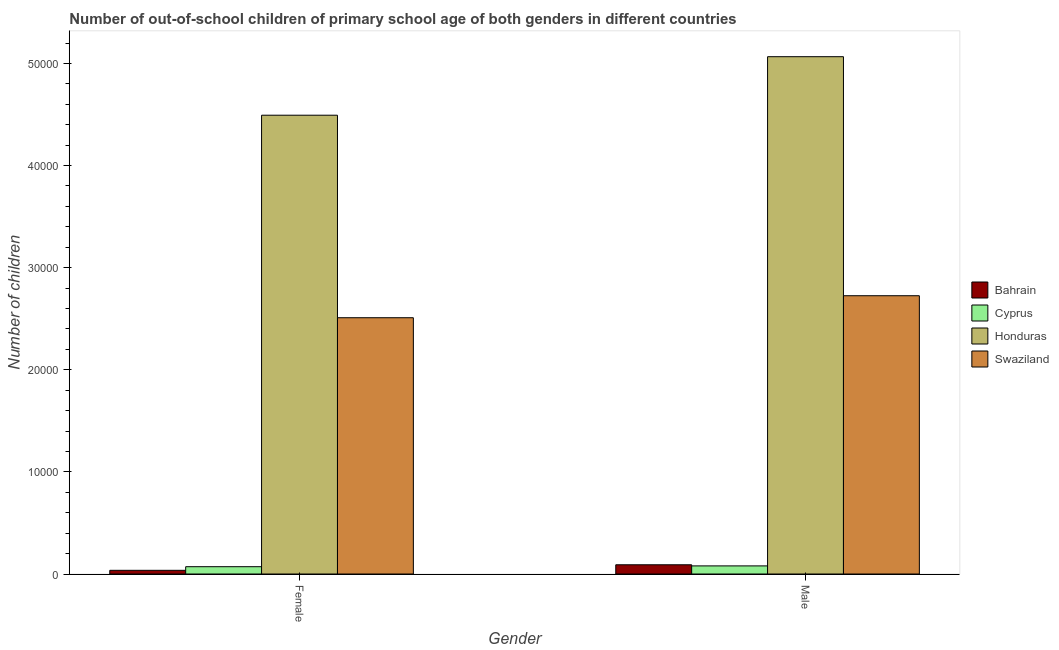How many different coloured bars are there?
Make the answer very short. 4. Are the number of bars per tick equal to the number of legend labels?
Offer a terse response. Yes. What is the label of the 1st group of bars from the left?
Make the answer very short. Female. What is the number of female out-of-school students in Honduras?
Your answer should be compact. 4.49e+04. Across all countries, what is the maximum number of female out-of-school students?
Provide a succinct answer. 4.49e+04. Across all countries, what is the minimum number of female out-of-school students?
Give a very brief answer. 360. In which country was the number of female out-of-school students maximum?
Keep it short and to the point. Honduras. In which country was the number of female out-of-school students minimum?
Make the answer very short. Bahrain. What is the total number of male out-of-school students in the graph?
Your response must be concise. 7.96e+04. What is the difference between the number of female out-of-school students in Swaziland and that in Cyprus?
Offer a terse response. 2.44e+04. What is the difference between the number of male out-of-school students in Bahrain and the number of female out-of-school students in Swaziland?
Make the answer very short. -2.42e+04. What is the average number of male out-of-school students per country?
Your response must be concise. 1.99e+04. What is the difference between the number of male out-of-school students and number of female out-of-school students in Cyprus?
Make the answer very short. 78. In how many countries, is the number of male out-of-school students greater than 12000 ?
Provide a succinct answer. 2. What is the ratio of the number of male out-of-school students in Swaziland to that in Cyprus?
Your answer should be compact. 34.37. What does the 1st bar from the left in Male represents?
Make the answer very short. Bahrain. What does the 1st bar from the right in Female represents?
Offer a terse response. Swaziland. How many bars are there?
Offer a terse response. 8. What is the difference between two consecutive major ticks on the Y-axis?
Give a very brief answer. 10000. Are the values on the major ticks of Y-axis written in scientific E-notation?
Ensure brevity in your answer.  No. Does the graph contain grids?
Give a very brief answer. No. How are the legend labels stacked?
Give a very brief answer. Vertical. What is the title of the graph?
Give a very brief answer. Number of out-of-school children of primary school age of both genders in different countries. What is the label or title of the Y-axis?
Make the answer very short. Number of children. What is the Number of children in Bahrain in Female?
Offer a terse response. 360. What is the Number of children of Cyprus in Female?
Your answer should be compact. 715. What is the Number of children of Honduras in Female?
Provide a succinct answer. 4.49e+04. What is the Number of children in Swaziland in Female?
Your answer should be compact. 2.51e+04. What is the Number of children in Bahrain in Male?
Your answer should be very brief. 904. What is the Number of children in Cyprus in Male?
Ensure brevity in your answer.  793. What is the Number of children in Honduras in Male?
Keep it short and to the point. 5.07e+04. What is the Number of children of Swaziland in Male?
Offer a terse response. 2.73e+04. Across all Gender, what is the maximum Number of children in Bahrain?
Your answer should be compact. 904. Across all Gender, what is the maximum Number of children in Cyprus?
Make the answer very short. 793. Across all Gender, what is the maximum Number of children in Honduras?
Provide a short and direct response. 5.07e+04. Across all Gender, what is the maximum Number of children of Swaziland?
Provide a succinct answer. 2.73e+04. Across all Gender, what is the minimum Number of children of Bahrain?
Provide a short and direct response. 360. Across all Gender, what is the minimum Number of children of Cyprus?
Provide a succinct answer. 715. Across all Gender, what is the minimum Number of children of Honduras?
Offer a terse response. 4.49e+04. Across all Gender, what is the minimum Number of children in Swaziland?
Your response must be concise. 2.51e+04. What is the total Number of children in Bahrain in the graph?
Ensure brevity in your answer.  1264. What is the total Number of children in Cyprus in the graph?
Offer a terse response. 1508. What is the total Number of children of Honduras in the graph?
Offer a very short reply. 9.56e+04. What is the total Number of children of Swaziland in the graph?
Ensure brevity in your answer.  5.24e+04. What is the difference between the Number of children in Bahrain in Female and that in Male?
Give a very brief answer. -544. What is the difference between the Number of children of Cyprus in Female and that in Male?
Keep it short and to the point. -78. What is the difference between the Number of children of Honduras in Female and that in Male?
Offer a terse response. -5731. What is the difference between the Number of children of Swaziland in Female and that in Male?
Your answer should be very brief. -2154. What is the difference between the Number of children in Bahrain in Female and the Number of children in Cyprus in Male?
Provide a short and direct response. -433. What is the difference between the Number of children in Bahrain in Female and the Number of children in Honduras in Male?
Your answer should be very brief. -5.03e+04. What is the difference between the Number of children in Bahrain in Female and the Number of children in Swaziland in Male?
Make the answer very short. -2.69e+04. What is the difference between the Number of children in Cyprus in Female and the Number of children in Honduras in Male?
Make the answer very short. -4.99e+04. What is the difference between the Number of children of Cyprus in Female and the Number of children of Swaziland in Male?
Provide a short and direct response. -2.65e+04. What is the difference between the Number of children in Honduras in Female and the Number of children in Swaziland in Male?
Your answer should be compact. 1.77e+04. What is the average Number of children of Bahrain per Gender?
Your answer should be very brief. 632. What is the average Number of children in Cyprus per Gender?
Offer a very short reply. 754. What is the average Number of children of Honduras per Gender?
Keep it short and to the point. 4.78e+04. What is the average Number of children in Swaziland per Gender?
Give a very brief answer. 2.62e+04. What is the difference between the Number of children of Bahrain and Number of children of Cyprus in Female?
Offer a very short reply. -355. What is the difference between the Number of children in Bahrain and Number of children in Honduras in Female?
Offer a terse response. -4.46e+04. What is the difference between the Number of children of Bahrain and Number of children of Swaziland in Female?
Offer a terse response. -2.47e+04. What is the difference between the Number of children of Cyprus and Number of children of Honduras in Female?
Your answer should be compact. -4.42e+04. What is the difference between the Number of children in Cyprus and Number of children in Swaziland in Female?
Make the answer very short. -2.44e+04. What is the difference between the Number of children in Honduras and Number of children in Swaziland in Female?
Provide a succinct answer. 1.98e+04. What is the difference between the Number of children in Bahrain and Number of children in Cyprus in Male?
Offer a terse response. 111. What is the difference between the Number of children in Bahrain and Number of children in Honduras in Male?
Ensure brevity in your answer.  -4.98e+04. What is the difference between the Number of children of Bahrain and Number of children of Swaziland in Male?
Keep it short and to the point. -2.63e+04. What is the difference between the Number of children in Cyprus and Number of children in Honduras in Male?
Ensure brevity in your answer.  -4.99e+04. What is the difference between the Number of children in Cyprus and Number of children in Swaziland in Male?
Ensure brevity in your answer.  -2.65e+04. What is the difference between the Number of children of Honduras and Number of children of Swaziland in Male?
Offer a terse response. 2.34e+04. What is the ratio of the Number of children in Bahrain in Female to that in Male?
Keep it short and to the point. 0.4. What is the ratio of the Number of children in Cyprus in Female to that in Male?
Offer a terse response. 0.9. What is the ratio of the Number of children of Honduras in Female to that in Male?
Make the answer very short. 0.89. What is the ratio of the Number of children of Swaziland in Female to that in Male?
Your answer should be compact. 0.92. What is the difference between the highest and the second highest Number of children of Bahrain?
Give a very brief answer. 544. What is the difference between the highest and the second highest Number of children of Honduras?
Ensure brevity in your answer.  5731. What is the difference between the highest and the second highest Number of children of Swaziland?
Your answer should be very brief. 2154. What is the difference between the highest and the lowest Number of children of Bahrain?
Provide a succinct answer. 544. What is the difference between the highest and the lowest Number of children of Honduras?
Your response must be concise. 5731. What is the difference between the highest and the lowest Number of children in Swaziland?
Your response must be concise. 2154. 